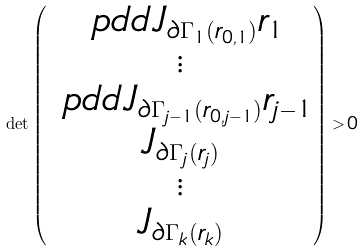Convert formula to latex. <formula><loc_0><loc_0><loc_500><loc_500>\det \begin{pmatrix} \ p d d { J _ { \partial \Gamma _ { 1 } ( r _ { 0 , 1 } ) } } { r _ { 1 } } \\ \vdots \\ \ p d d { J _ { \partial \Gamma _ { j - 1 } ( r _ { 0 , j - 1 } ) } } { r _ { j - 1 } } \\ J _ { \partial \Gamma _ { j } ( r _ { j } ) } \\ \vdots \\ J _ { \partial \Gamma _ { k } ( r _ { k } ) } \end{pmatrix} > 0</formula> 